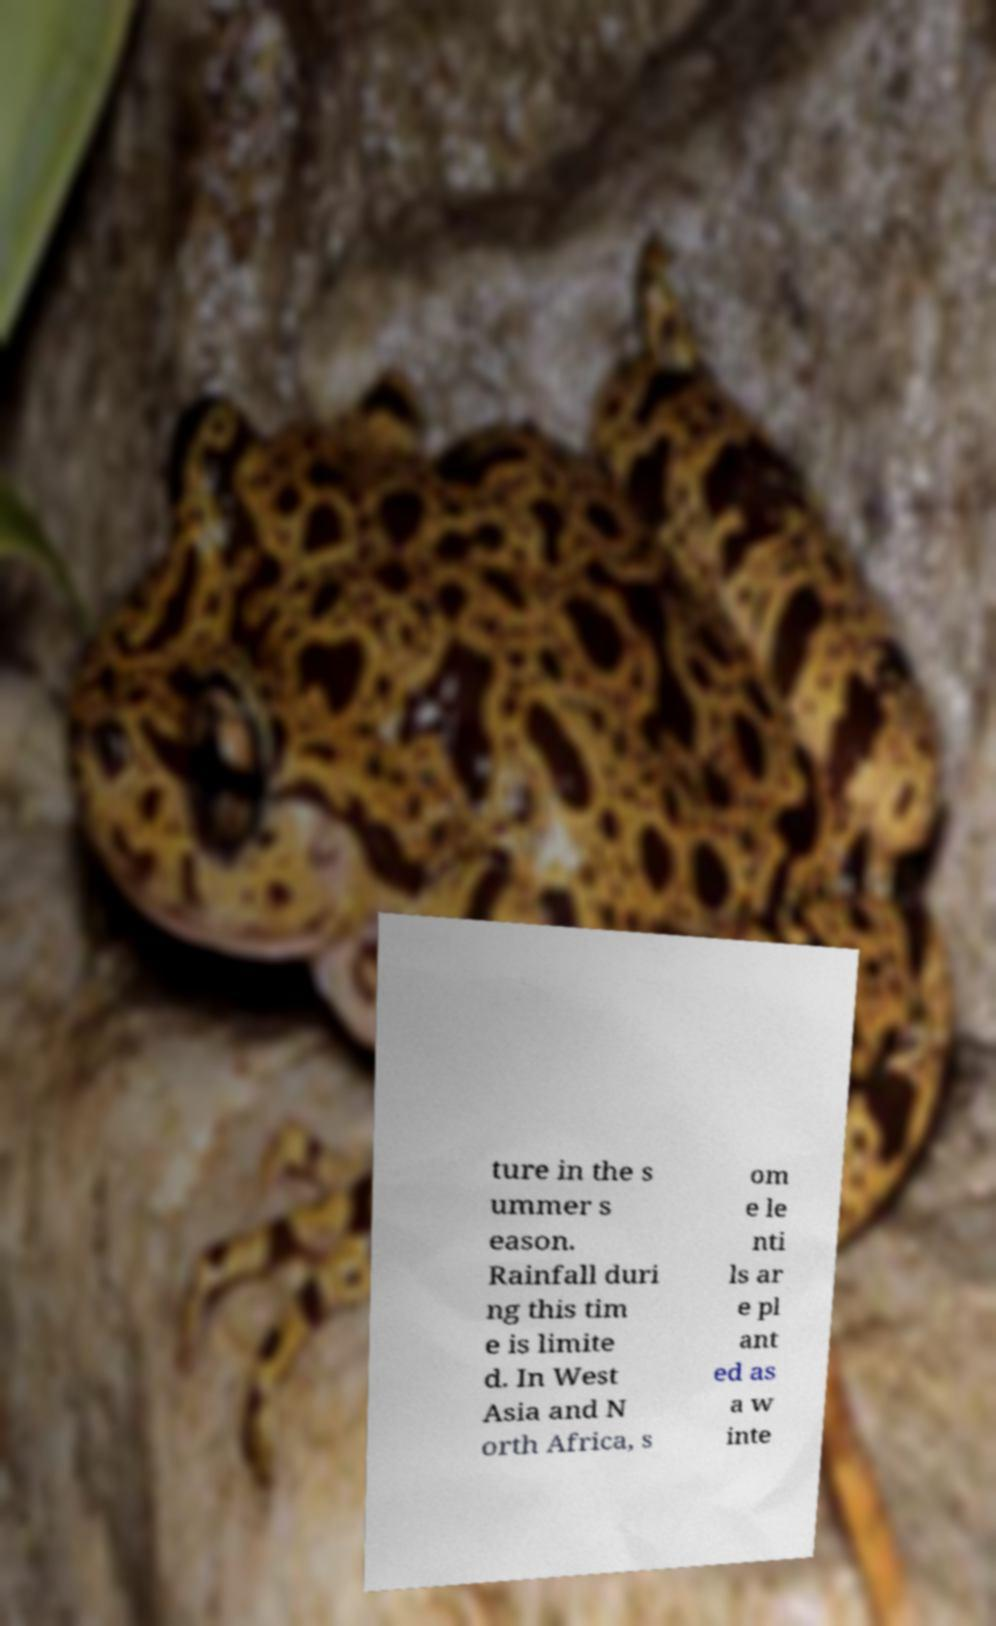Can you read and provide the text displayed in the image?This photo seems to have some interesting text. Can you extract and type it out for me? ture in the s ummer s eason. Rainfall duri ng this tim e is limite d. In West Asia and N orth Africa, s om e le nti ls ar e pl ant ed as a w inte 